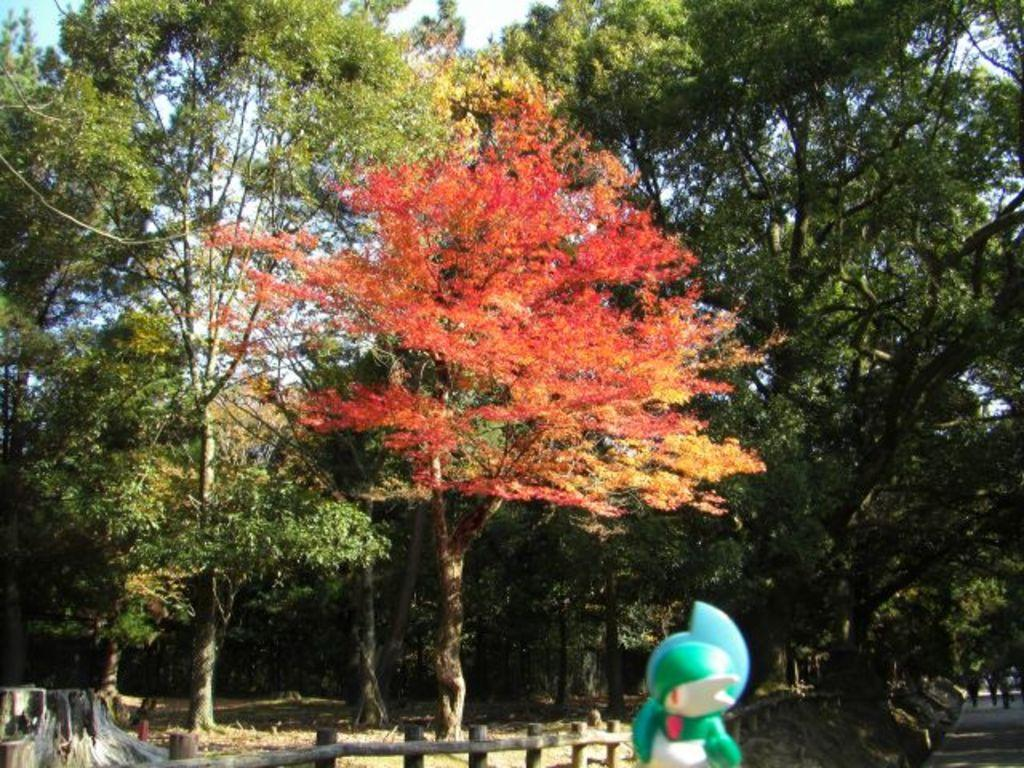What is located at the bottom of the image? There is an object at the bottom of the image. What can be seen in the middle of the image? There are trees in the middle of the image. What is visible in the background of the image? The sky is visible in the background of the image. What type of fruit is hanging from the trees in the image? There is no fruit visible in the image; only trees are present. Can you see an owl perched on one of the branches in the image? There is no owl present in the image; only trees are visible. 